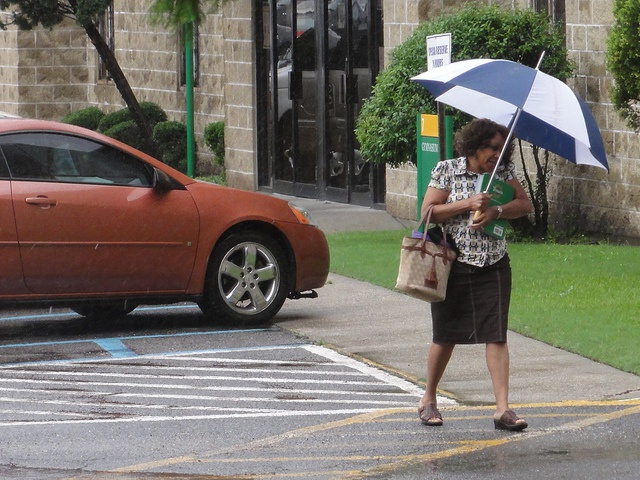Describe the objects in this image and their specific colors. I can see car in black, maroon, gray, and brown tones, people in black, gray, darkgray, and maroon tones, umbrella in black, lavender, navy, and gray tones, handbag in black, gray, and darkgray tones, and book in black, darkgreen, gray, and darkgray tones in this image. 